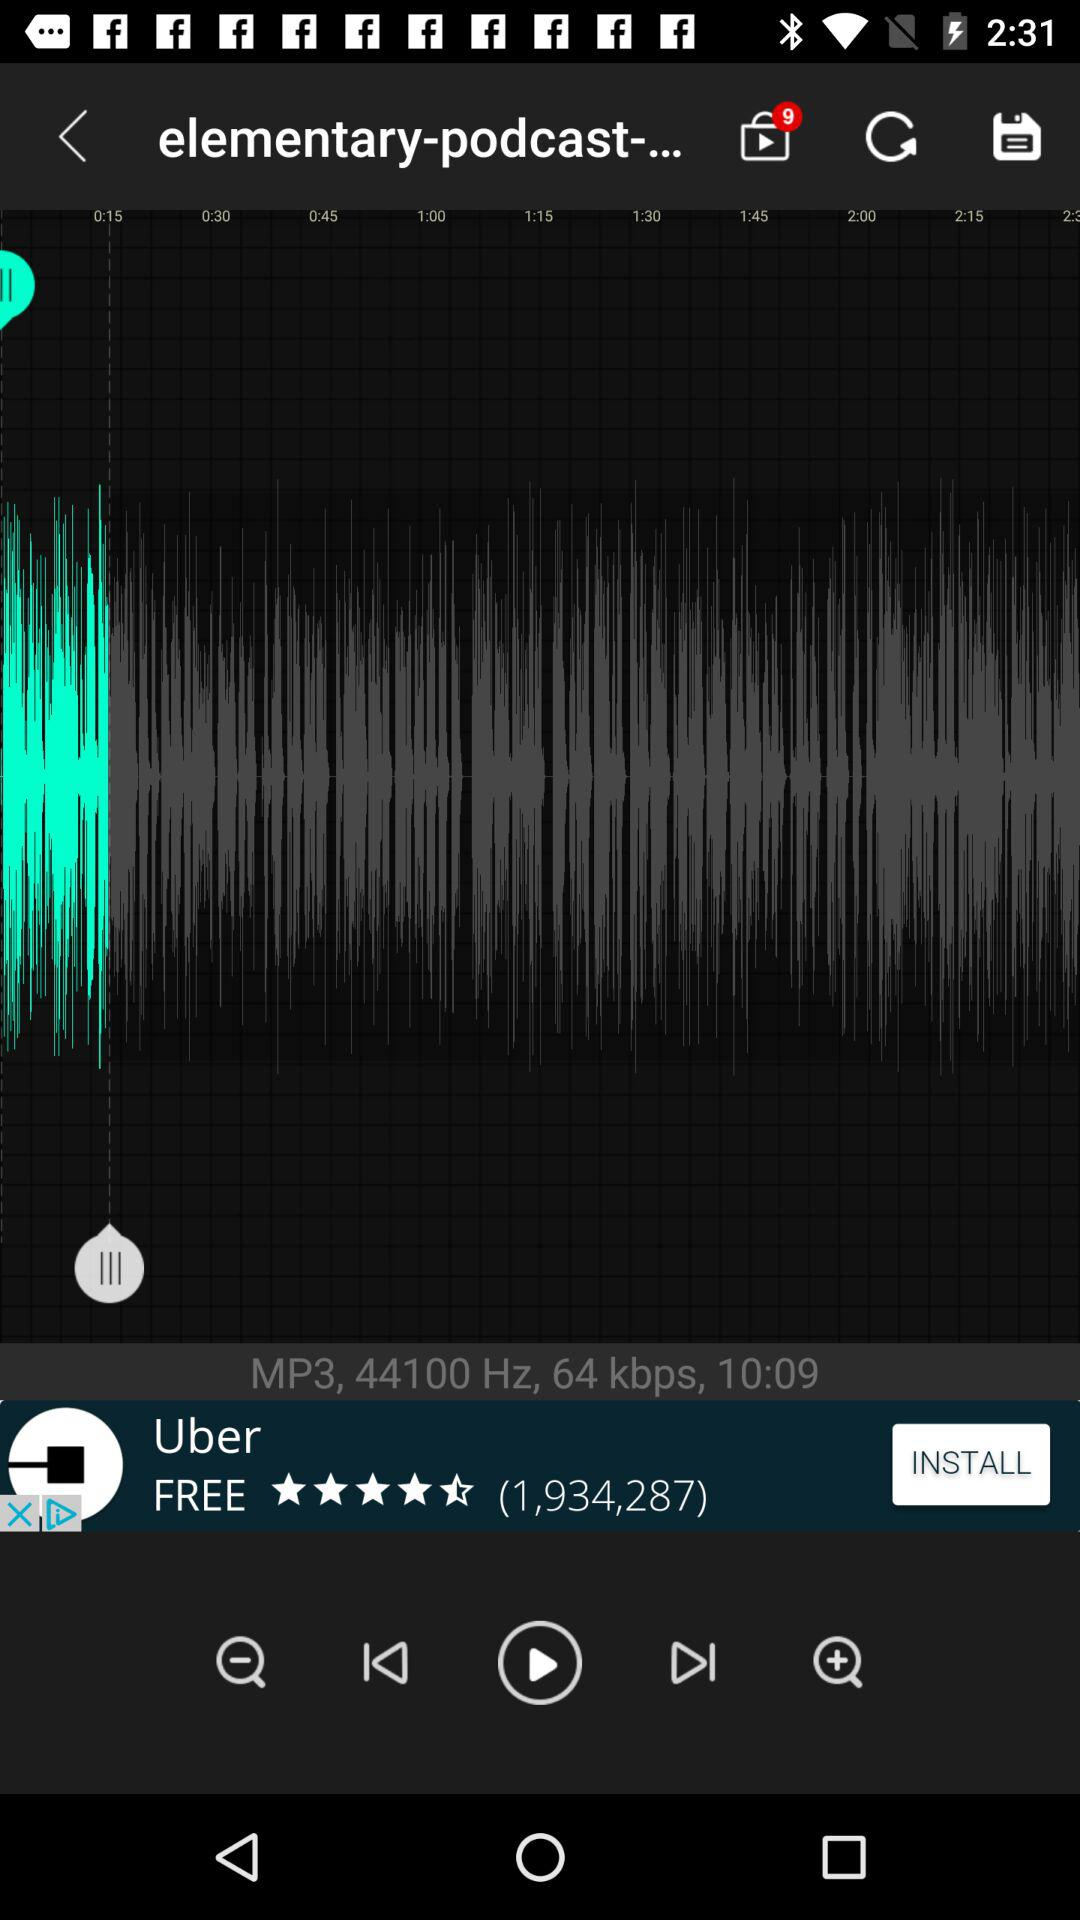What is the speed? The speed is 64 kbps. 